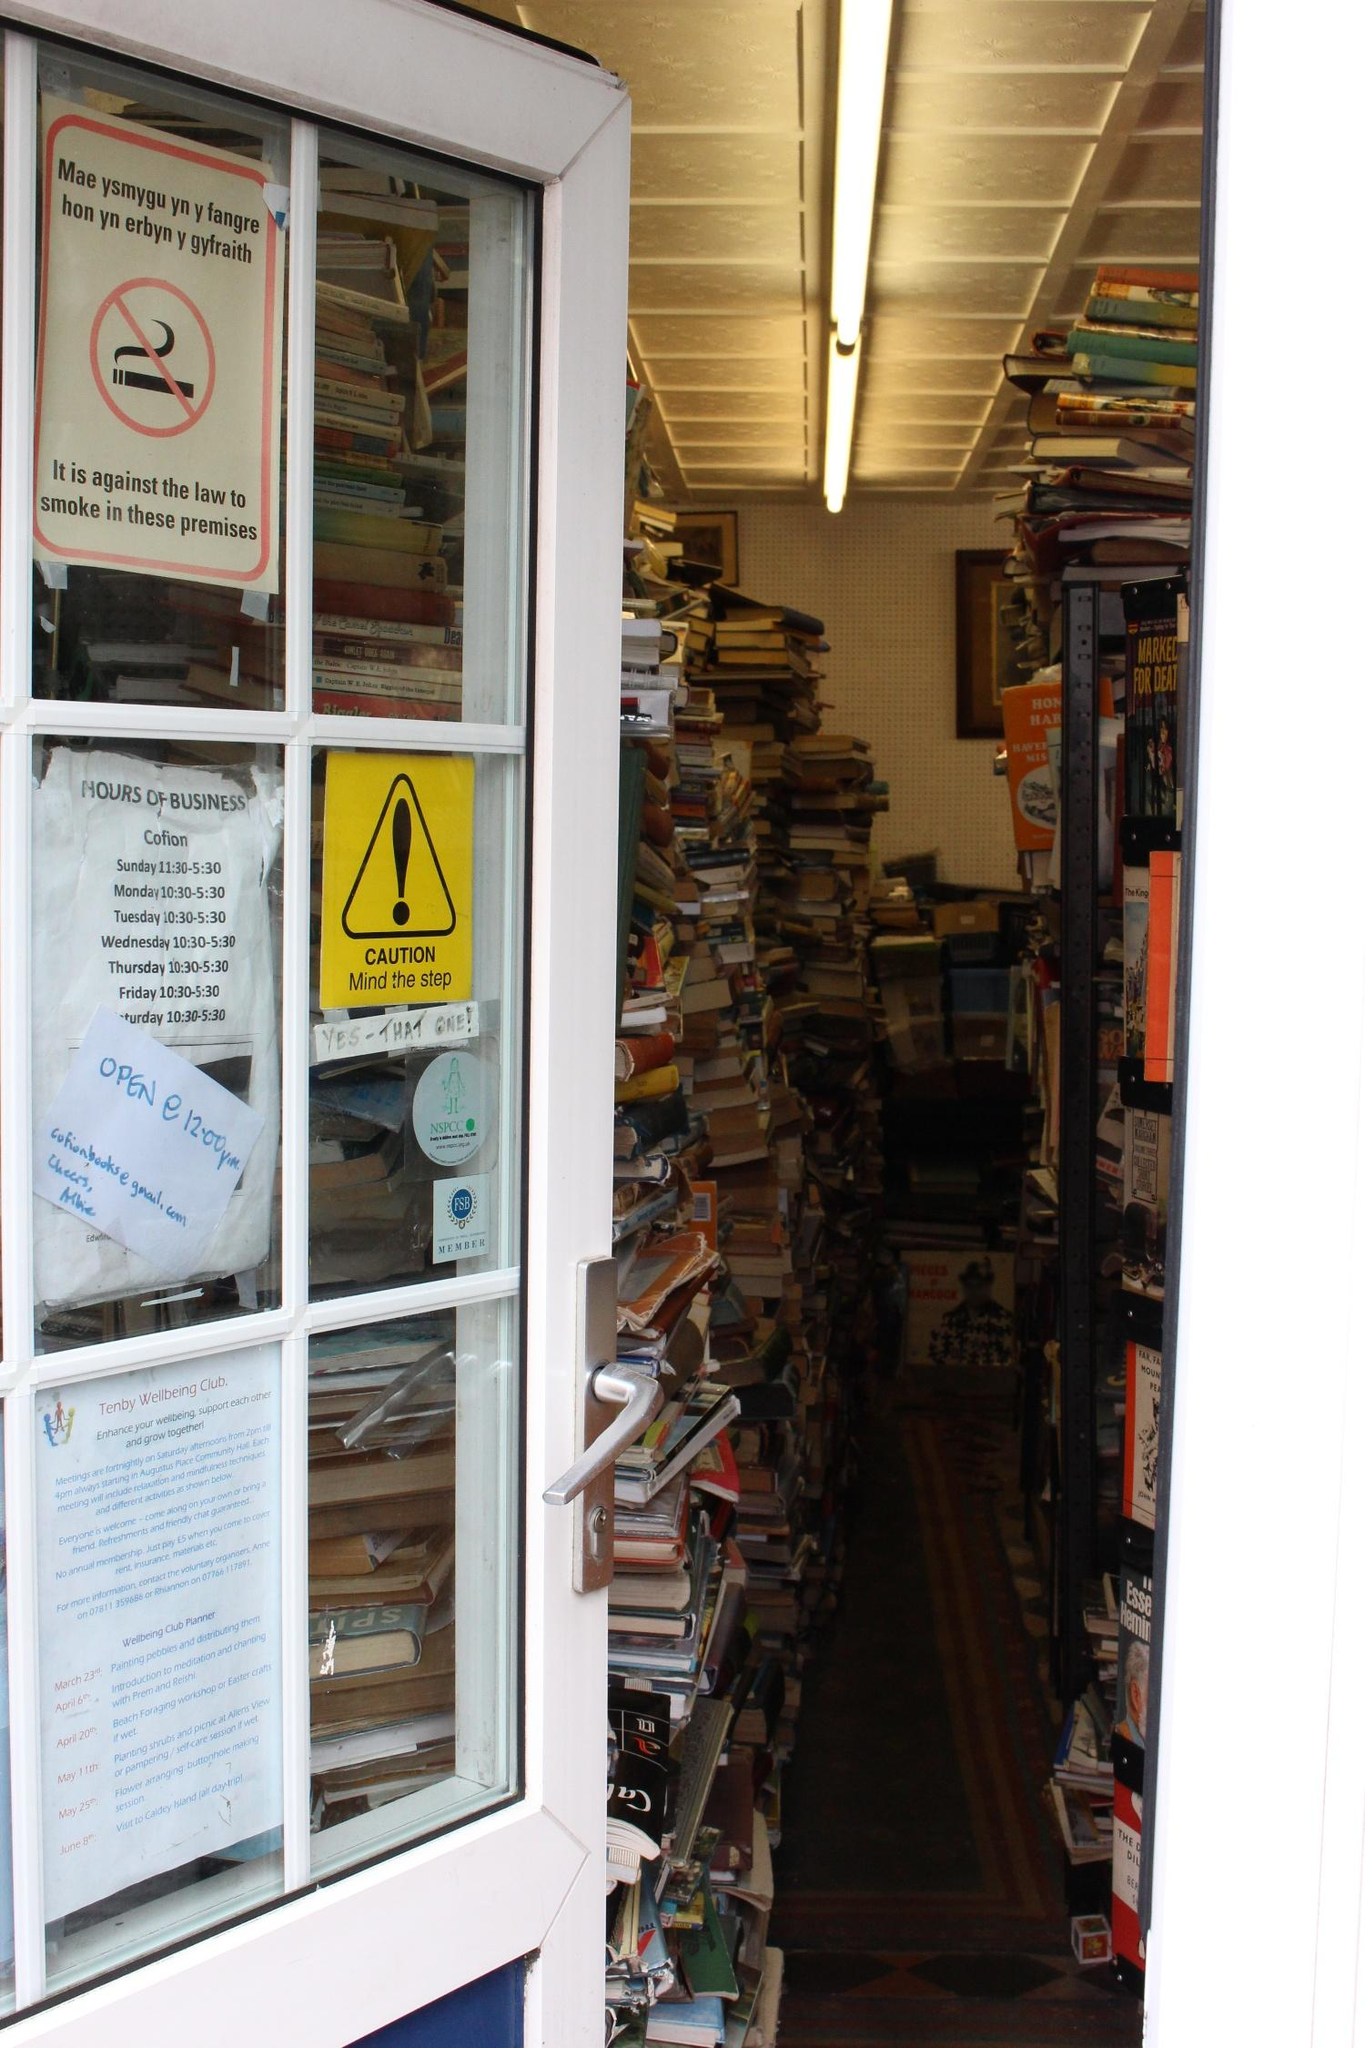Could you describe the interior of the bookstore? The interior of the bookstore is a compelling cascade of literary chaos. Books are stacked in a seemingly precarious manner, yet there's an underlying systematic approach that only a seasoned bibliophile might understand. Varying in color, size, and presumably subject, the books create a rich tapestry that hints at the vast range of ideas and adventures waiting within their pages. The space is narrow, suggesting an intimate browsing experience. Tube lighting bathes the interior in a soft, evenly distributed light, aiding in the exploration of the titles on offer. In the background, you can glimpse a hint of a checkout counter and some promotional posters, completing the essence of an independent bookstore. 